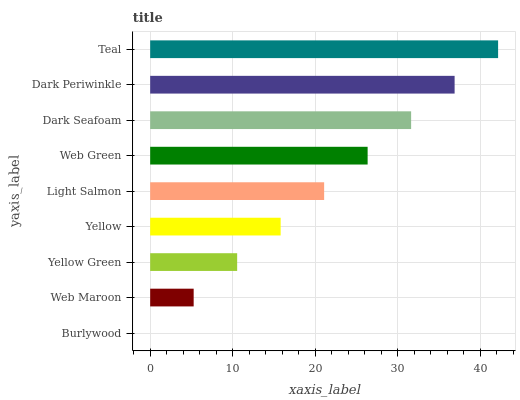Is Burlywood the minimum?
Answer yes or no. Yes. Is Teal the maximum?
Answer yes or no. Yes. Is Web Maroon the minimum?
Answer yes or no. No. Is Web Maroon the maximum?
Answer yes or no. No. Is Web Maroon greater than Burlywood?
Answer yes or no. Yes. Is Burlywood less than Web Maroon?
Answer yes or no. Yes. Is Burlywood greater than Web Maroon?
Answer yes or no. No. Is Web Maroon less than Burlywood?
Answer yes or no. No. Is Light Salmon the high median?
Answer yes or no. Yes. Is Light Salmon the low median?
Answer yes or no. Yes. Is Yellow the high median?
Answer yes or no. No. Is Web Maroon the low median?
Answer yes or no. No. 